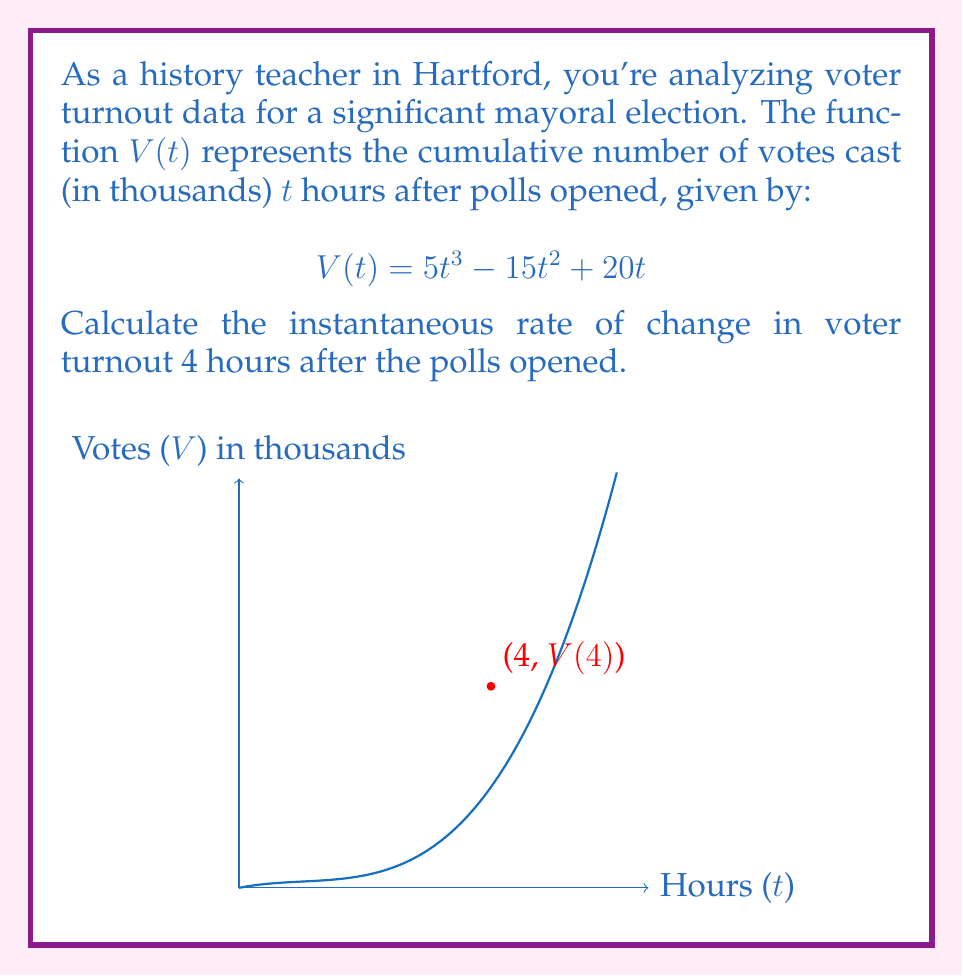Could you help me with this problem? To find the instantaneous rate of change, we need to calculate the derivative of $V(t)$ and evaluate it at $t=4$. Let's break this down step-by-step:

1) First, let's find the derivative $V'(t)$ using the power rule:
   
   $$V'(t) = \frac{d}{dt}(5t^3 - 15t^2 + 20t)$$
   $$V'(t) = 15t^2 - 30t + 20$$

2) Now, we need to evaluate $V'(4)$:
   
   $$V'(4) = 15(4)^2 - 30(4) + 20$$
   $$V'(4) = 15(16) - 120 + 20$$
   $$V'(4) = 240 - 120 + 20$$
   $$V'(4) = 140$$

3) Interpret the result:
   The instantaneous rate of change 4 hours after the polls opened is 140 votes per hour.

This rate represents how quickly votes were being cast at exactly 4 hours after the polls opened. As a history teacher, you might relate this to the urgency of civic participation during key moments in Hartford's electoral history.
Answer: 140 votes per hour 